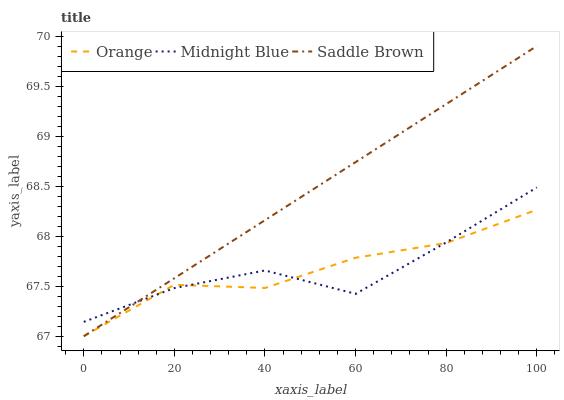Does Midnight Blue have the minimum area under the curve?
Answer yes or no. Yes. Does Saddle Brown have the maximum area under the curve?
Answer yes or no. Yes. Does Saddle Brown have the minimum area under the curve?
Answer yes or no. No. Does Midnight Blue have the maximum area under the curve?
Answer yes or no. No. Is Saddle Brown the smoothest?
Answer yes or no. Yes. Is Midnight Blue the roughest?
Answer yes or no. Yes. Is Midnight Blue the smoothest?
Answer yes or no. No. Is Saddle Brown the roughest?
Answer yes or no. No. Does Orange have the lowest value?
Answer yes or no. Yes. Does Midnight Blue have the lowest value?
Answer yes or no. No. Does Saddle Brown have the highest value?
Answer yes or no. Yes. Does Midnight Blue have the highest value?
Answer yes or no. No. Does Orange intersect Midnight Blue?
Answer yes or no. Yes. Is Orange less than Midnight Blue?
Answer yes or no. No. Is Orange greater than Midnight Blue?
Answer yes or no. No. 